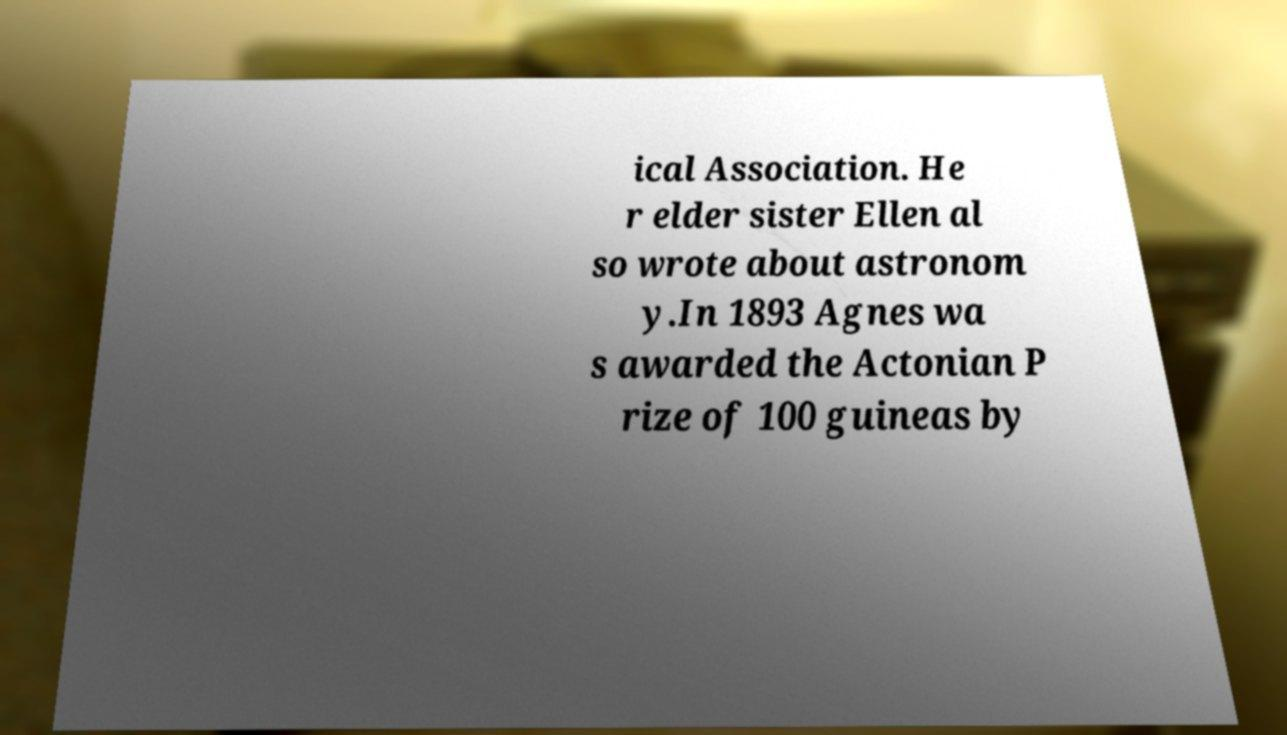Can you read and provide the text displayed in the image?This photo seems to have some interesting text. Can you extract and type it out for me? ical Association. He r elder sister Ellen al so wrote about astronom y.In 1893 Agnes wa s awarded the Actonian P rize of 100 guineas by 